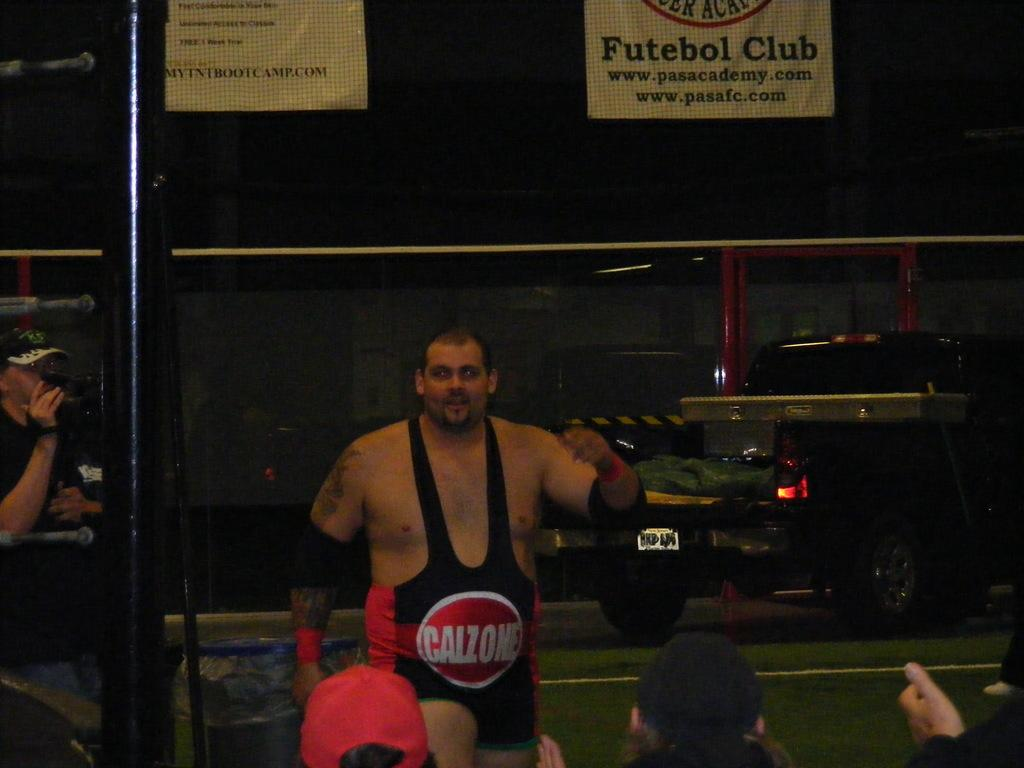Provide a one-sentence caption for the provided image. A man is wearing a wrestling uniform with a large red circle saying Calzone on the belly. 